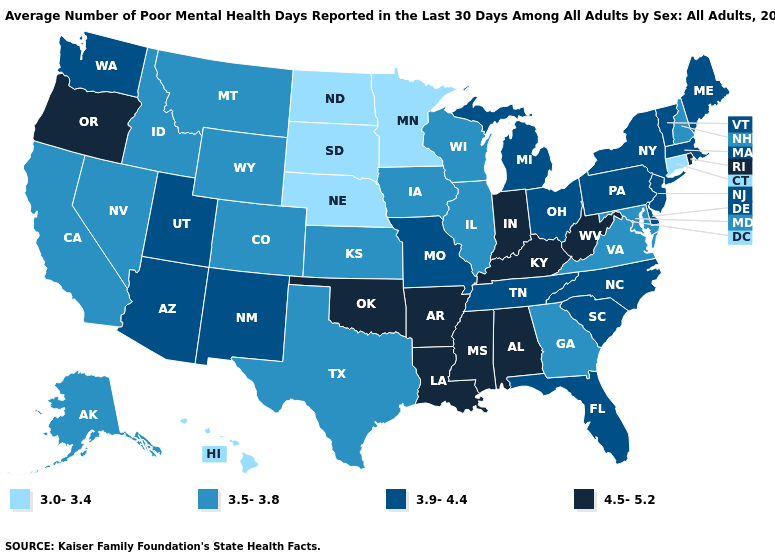Name the states that have a value in the range 3.0-3.4?
Concise answer only. Connecticut, Hawaii, Minnesota, Nebraska, North Dakota, South Dakota. Does the first symbol in the legend represent the smallest category?
Be succinct. Yes. What is the lowest value in states that border Florida?
Write a very short answer. 3.5-3.8. What is the value of Michigan?
Answer briefly. 3.9-4.4. What is the value of Delaware?
Write a very short answer. 3.9-4.4. Which states hav the highest value in the South?
Concise answer only. Alabama, Arkansas, Kentucky, Louisiana, Mississippi, Oklahoma, West Virginia. Name the states that have a value in the range 4.5-5.2?
Give a very brief answer. Alabama, Arkansas, Indiana, Kentucky, Louisiana, Mississippi, Oklahoma, Oregon, Rhode Island, West Virginia. What is the highest value in states that border North Carolina?
Give a very brief answer. 3.9-4.4. Does Hawaii have the lowest value in the West?
Quick response, please. Yes. Name the states that have a value in the range 4.5-5.2?
Quick response, please. Alabama, Arkansas, Indiana, Kentucky, Louisiana, Mississippi, Oklahoma, Oregon, Rhode Island, West Virginia. Does the first symbol in the legend represent the smallest category?
Answer briefly. Yes. Does Iowa have the highest value in the MidWest?
Give a very brief answer. No. What is the lowest value in the USA?
Keep it brief. 3.0-3.4. Among the states that border Louisiana , which have the highest value?
Keep it brief. Arkansas, Mississippi. Name the states that have a value in the range 3.5-3.8?
Write a very short answer. Alaska, California, Colorado, Georgia, Idaho, Illinois, Iowa, Kansas, Maryland, Montana, Nevada, New Hampshire, Texas, Virginia, Wisconsin, Wyoming. 